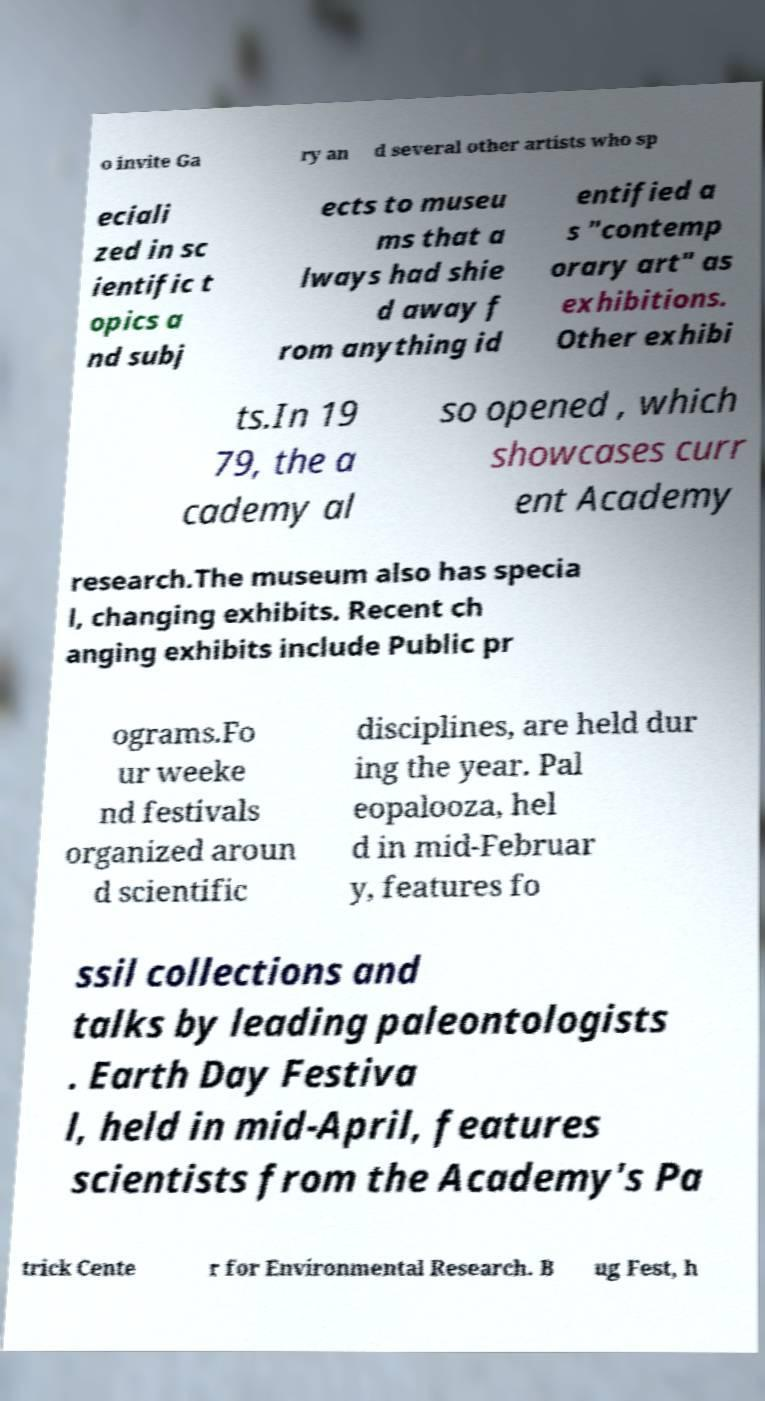What messages or text are displayed in this image? I need them in a readable, typed format. o invite Ga ry an d several other artists who sp eciali zed in sc ientific t opics a nd subj ects to museu ms that a lways had shie d away f rom anything id entified a s "contemp orary art" as exhibitions. Other exhibi ts.In 19 79, the a cademy al so opened , which showcases curr ent Academy research.The museum also has specia l, changing exhibits. Recent ch anging exhibits include Public pr ograms.Fo ur weeke nd festivals organized aroun d scientific disciplines, are held dur ing the year. Pal eopalooza, hel d in mid-Februar y, features fo ssil collections and talks by leading paleontologists . Earth Day Festiva l, held in mid-April, features scientists from the Academy's Pa trick Cente r for Environmental Research. B ug Fest, h 